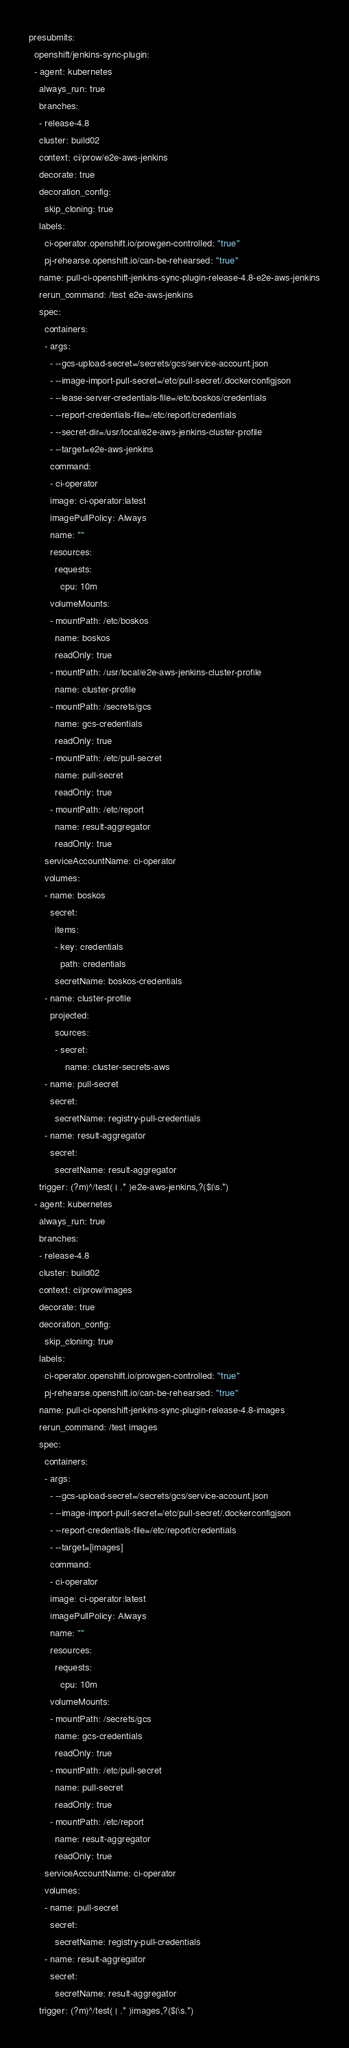Convert code to text. <code><loc_0><loc_0><loc_500><loc_500><_YAML_>presubmits:
  openshift/jenkins-sync-plugin:
  - agent: kubernetes
    always_run: true
    branches:
    - release-4.8
    cluster: build02
    context: ci/prow/e2e-aws-jenkins
    decorate: true
    decoration_config:
      skip_cloning: true
    labels:
      ci-operator.openshift.io/prowgen-controlled: "true"
      pj-rehearse.openshift.io/can-be-rehearsed: "true"
    name: pull-ci-openshift-jenkins-sync-plugin-release-4.8-e2e-aws-jenkins
    rerun_command: /test e2e-aws-jenkins
    spec:
      containers:
      - args:
        - --gcs-upload-secret=/secrets/gcs/service-account.json
        - --image-import-pull-secret=/etc/pull-secret/.dockerconfigjson
        - --lease-server-credentials-file=/etc/boskos/credentials
        - --report-credentials-file=/etc/report/credentials
        - --secret-dir=/usr/local/e2e-aws-jenkins-cluster-profile
        - --target=e2e-aws-jenkins
        command:
        - ci-operator
        image: ci-operator:latest
        imagePullPolicy: Always
        name: ""
        resources:
          requests:
            cpu: 10m
        volumeMounts:
        - mountPath: /etc/boskos
          name: boskos
          readOnly: true
        - mountPath: /usr/local/e2e-aws-jenkins-cluster-profile
          name: cluster-profile
        - mountPath: /secrets/gcs
          name: gcs-credentials
          readOnly: true
        - mountPath: /etc/pull-secret
          name: pull-secret
          readOnly: true
        - mountPath: /etc/report
          name: result-aggregator
          readOnly: true
      serviceAccountName: ci-operator
      volumes:
      - name: boskos
        secret:
          items:
          - key: credentials
            path: credentials
          secretName: boskos-credentials
      - name: cluster-profile
        projected:
          sources:
          - secret:
              name: cluster-secrets-aws
      - name: pull-secret
        secret:
          secretName: registry-pull-credentials
      - name: result-aggregator
        secret:
          secretName: result-aggregator
    trigger: (?m)^/test( | .* )e2e-aws-jenkins,?($|\s.*)
  - agent: kubernetes
    always_run: true
    branches:
    - release-4.8
    cluster: build02
    context: ci/prow/images
    decorate: true
    decoration_config:
      skip_cloning: true
    labels:
      ci-operator.openshift.io/prowgen-controlled: "true"
      pj-rehearse.openshift.io/can-be-rehearsed: "true"
    name: pull-ci-openshift-jenkins-sync-plugin-release-4.8-images
    rerun_command: /test images
    spec:
      containers:
      - args:
        - --gcs-upload-secret=/secrets/gcs/service-account.json
        - --image-import-pull-secret=/etc/pull-secret/.dockerconfigjson
        - --report-credentials-file=/etc/report/credentials
        - --target=[images]
        command:
        - ci-operator
        image: ci-operator:latest
        imagePullPolicy: Always
        name: ""
        resources:
          requests:
            cpu: 10m
        volumeMounts:
        - mountPath: /secrets/gcs
          name: gcs-credentials
          readOnly: true
        - mountPath: /etc/pull-secret
          name: pull-secret
          readOnly: true
        - mountPath: /etc/report
          name: result-aggregator
          readOnly: true
      serviceAccountName: ci-operator
      volumes:
      - name: pull-secret
        secret:
          secretName: registry-pull-credentials
      - name: result-aggregator
        secret:
          secretName: result-aggregator
    trigger: (?m)^/test( | .* )images,?($|\s.*)
</code> 